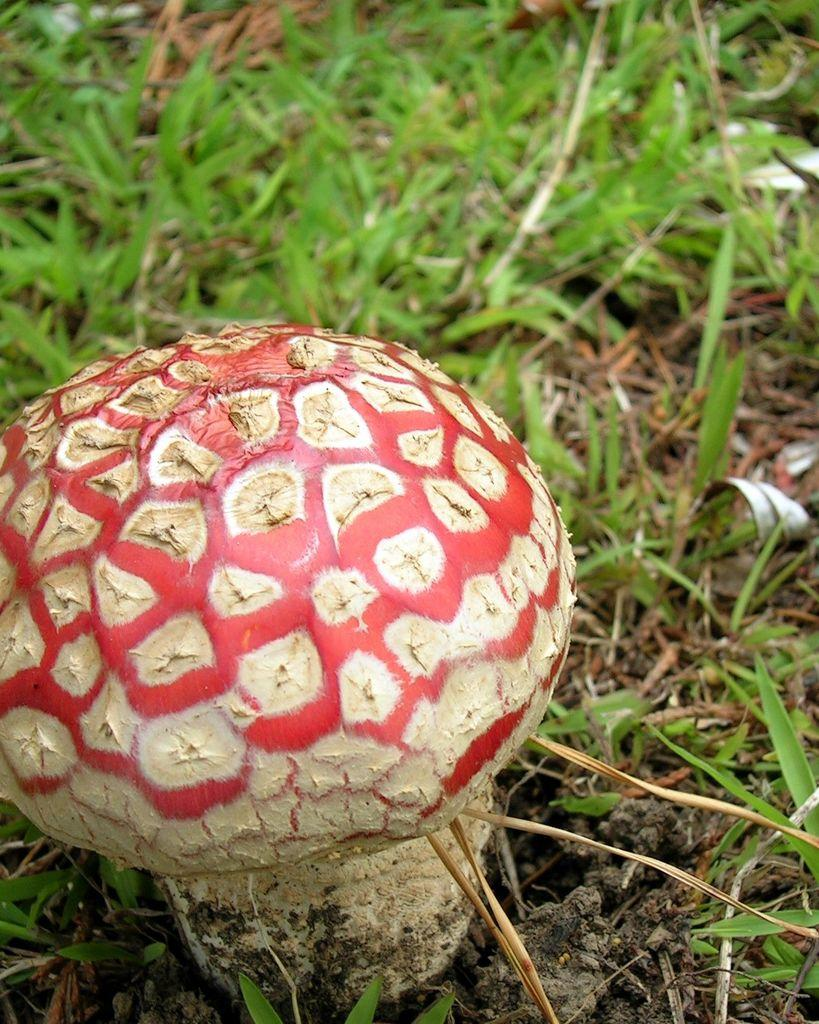What type of vegetation can be seen in the image? There is grass in the image. Are there any other plants or fungi visible in the image? Yes, there is a mushroom in the image. What type of stamp can be seen on the mushroom in the image? There is no stamp present on the mushroom in the image. What achievements has the grass in the image accomplished? The grass in the image is not an achiever, as it is a plant and does not have the ability to accomplish achievements. 